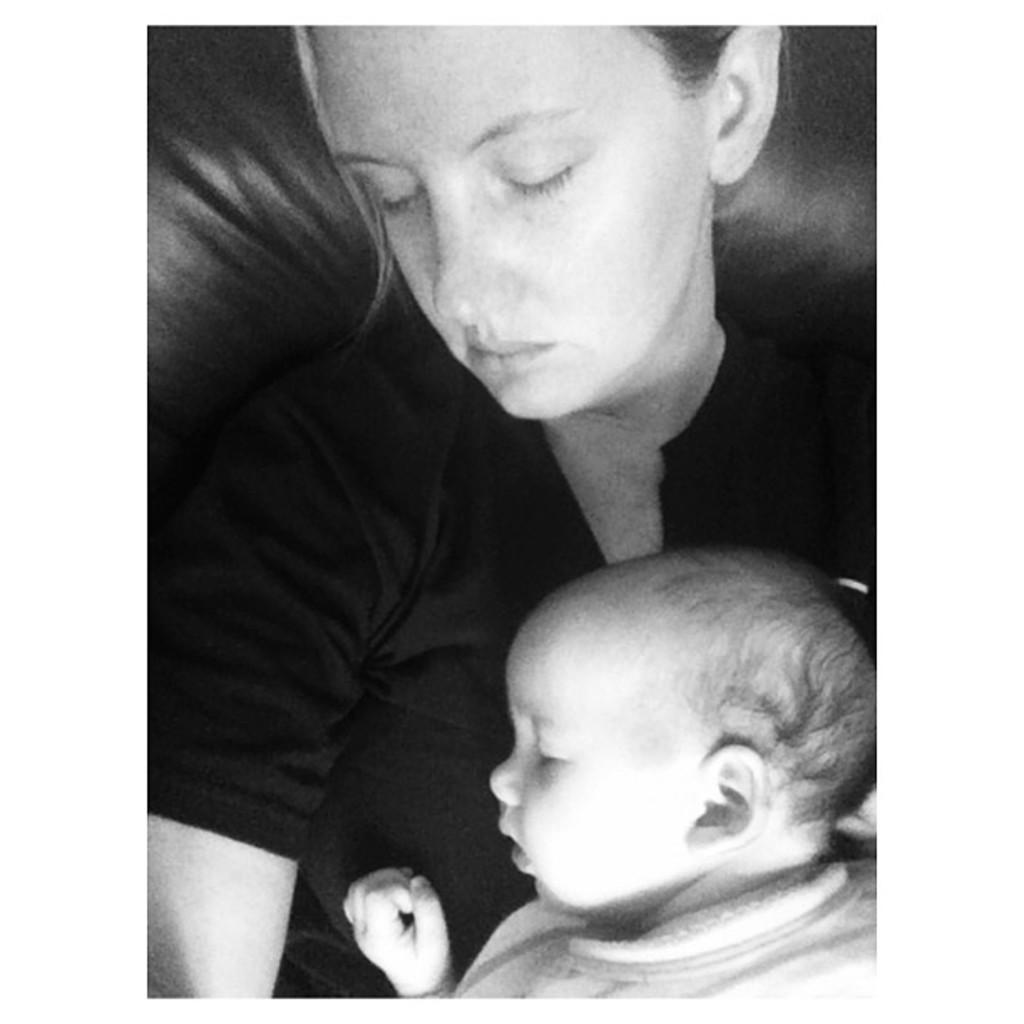What is the color scheme of the image? The image is black and white. Who is present in the image? There is a woman and a baby in the image. What news is the baby sharing with the woman in the image? There is no news being shared in the image, as it is a black and white image of a woman and a baby. What feeling is the woman expressing in the image? The image does not convey any specific feelings or emotions, as it is in black and white and does not show facial expressions or body language in detail. 